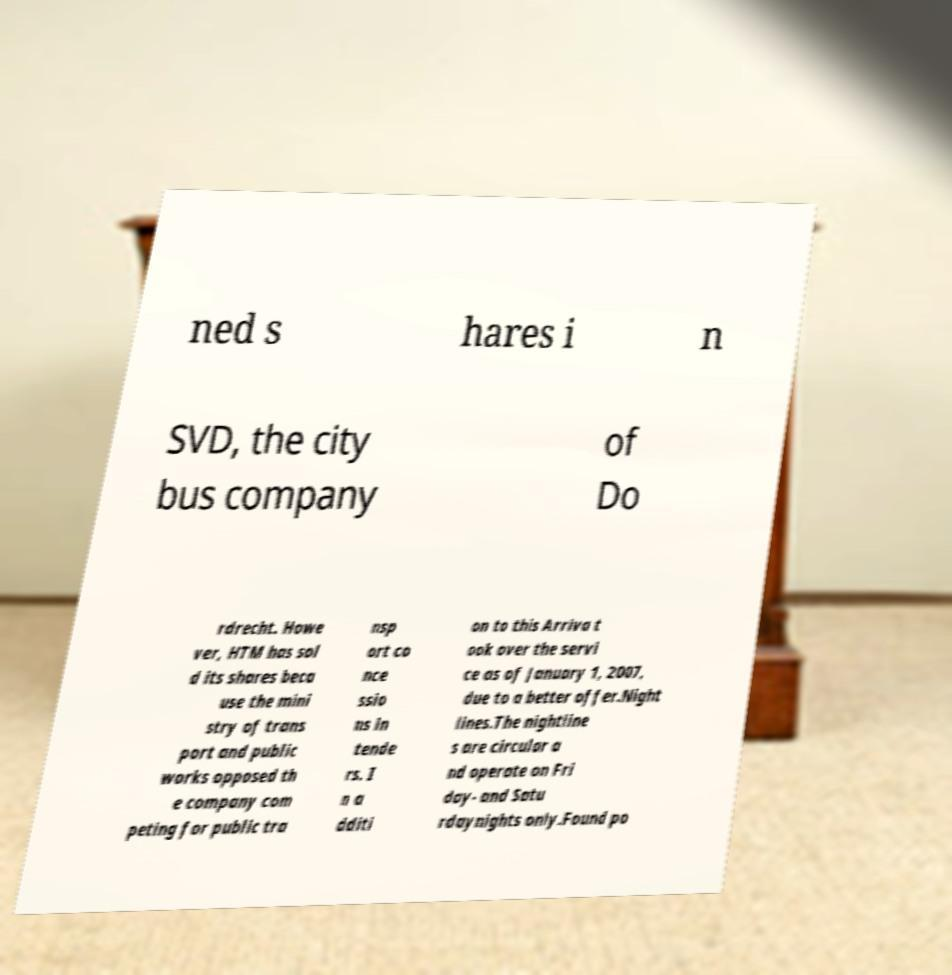Can you read and provide the text displayed in the image?This photo seems to have some interesting text. Can you extract and type it out for me? ned s hares i n SVD, the city bus company of Do rdrecht. Howe ver, HTM has sol d its shares beca use the mini stry of trans port and public works opposed th e company com peting for public tra nsp ort co nce ssio ns in tende rs. I n a dditi on to this Arriva t ook over the servi ce as of January 1, 2007, due to a better offer.Night lines.The nightline s are circular a nd operate on Fri day- and Satu rdaynights only.Found po 